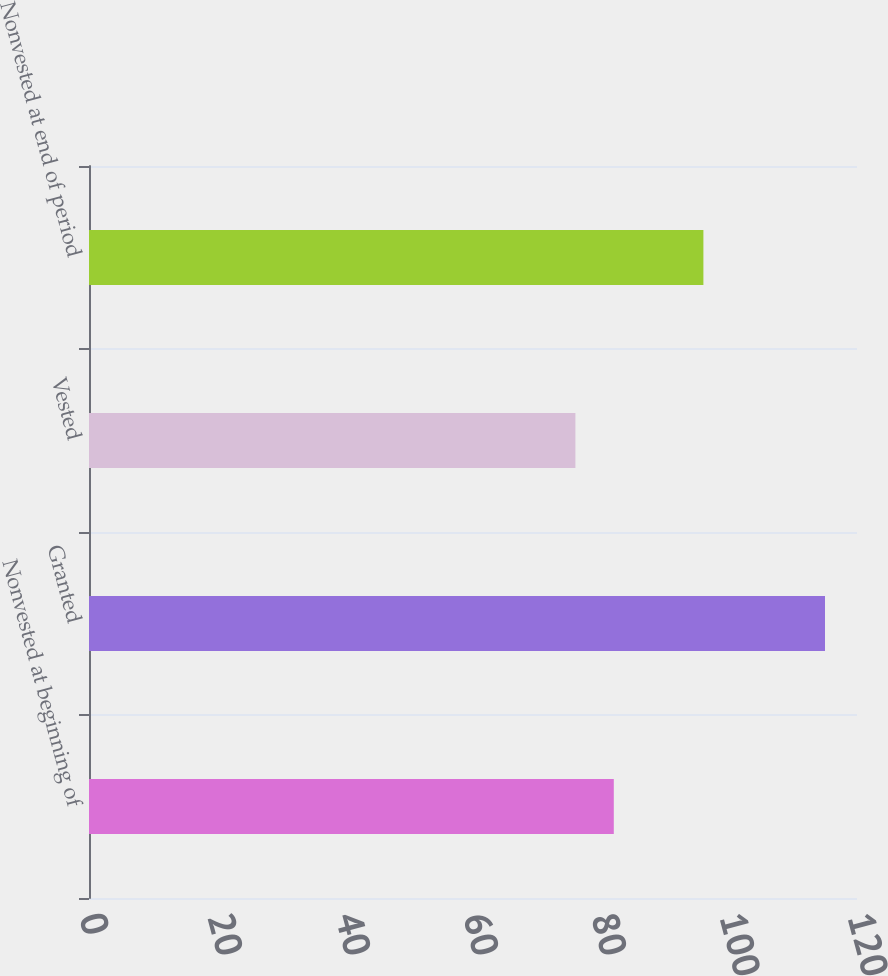Convert chart. <chart><loc_0><loc_0><loc_500><loc_500><bar_chart><fcel>Nonvested at beginning of<fcel>Granted<fcel>Vested<fcel>Nonvested at end of period<nl><fcel>82<fcel>115<fcel>76<fcel>96<nl></chart> 